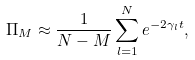<formula> <loc_0><loc_0><loc_500><loc_500>\Pi _ { M } \approx \frac { 1 } { N - M } \sum _ { l = 1 } ^ { N } e ^ { - 2 \gamma _ { l } t } ,</formula> 